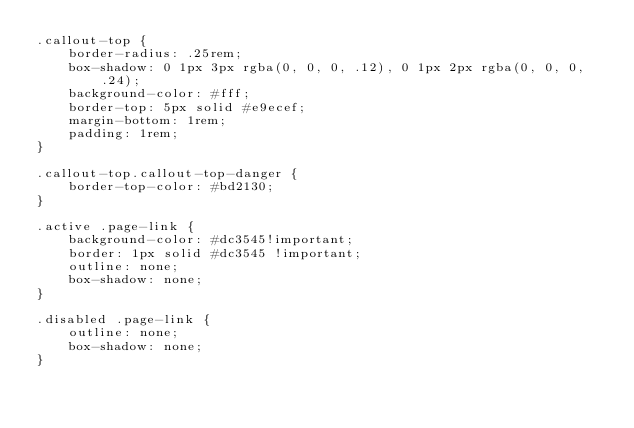Convert code to text. <code><loc_0><loc_0><loc_500><loc_500><_CSS_>.callout-top {
    border-radius: .25rem;
    box-shadow: 0 1px 3px rgba(0, 0, 0, .12), 0 1px 2px rgba(0, 0, 0, .24);
    background-color: #fff;
    border-top: 5px solid #e9ecef;
    margin-bottom: 1rem;
    padding: 1rem;
}

.callout-top.callout-top-danger {
    border-top-color: #bd2130;
}

.active .page-link {
    background-color: #dc3545!important;
    border: 1px solid #dc3545 !important;
    outline: none;
    box-shadow: none;
}

.disabled .page-link {
    outline: none;
    box-shadow: none;
}</code> 